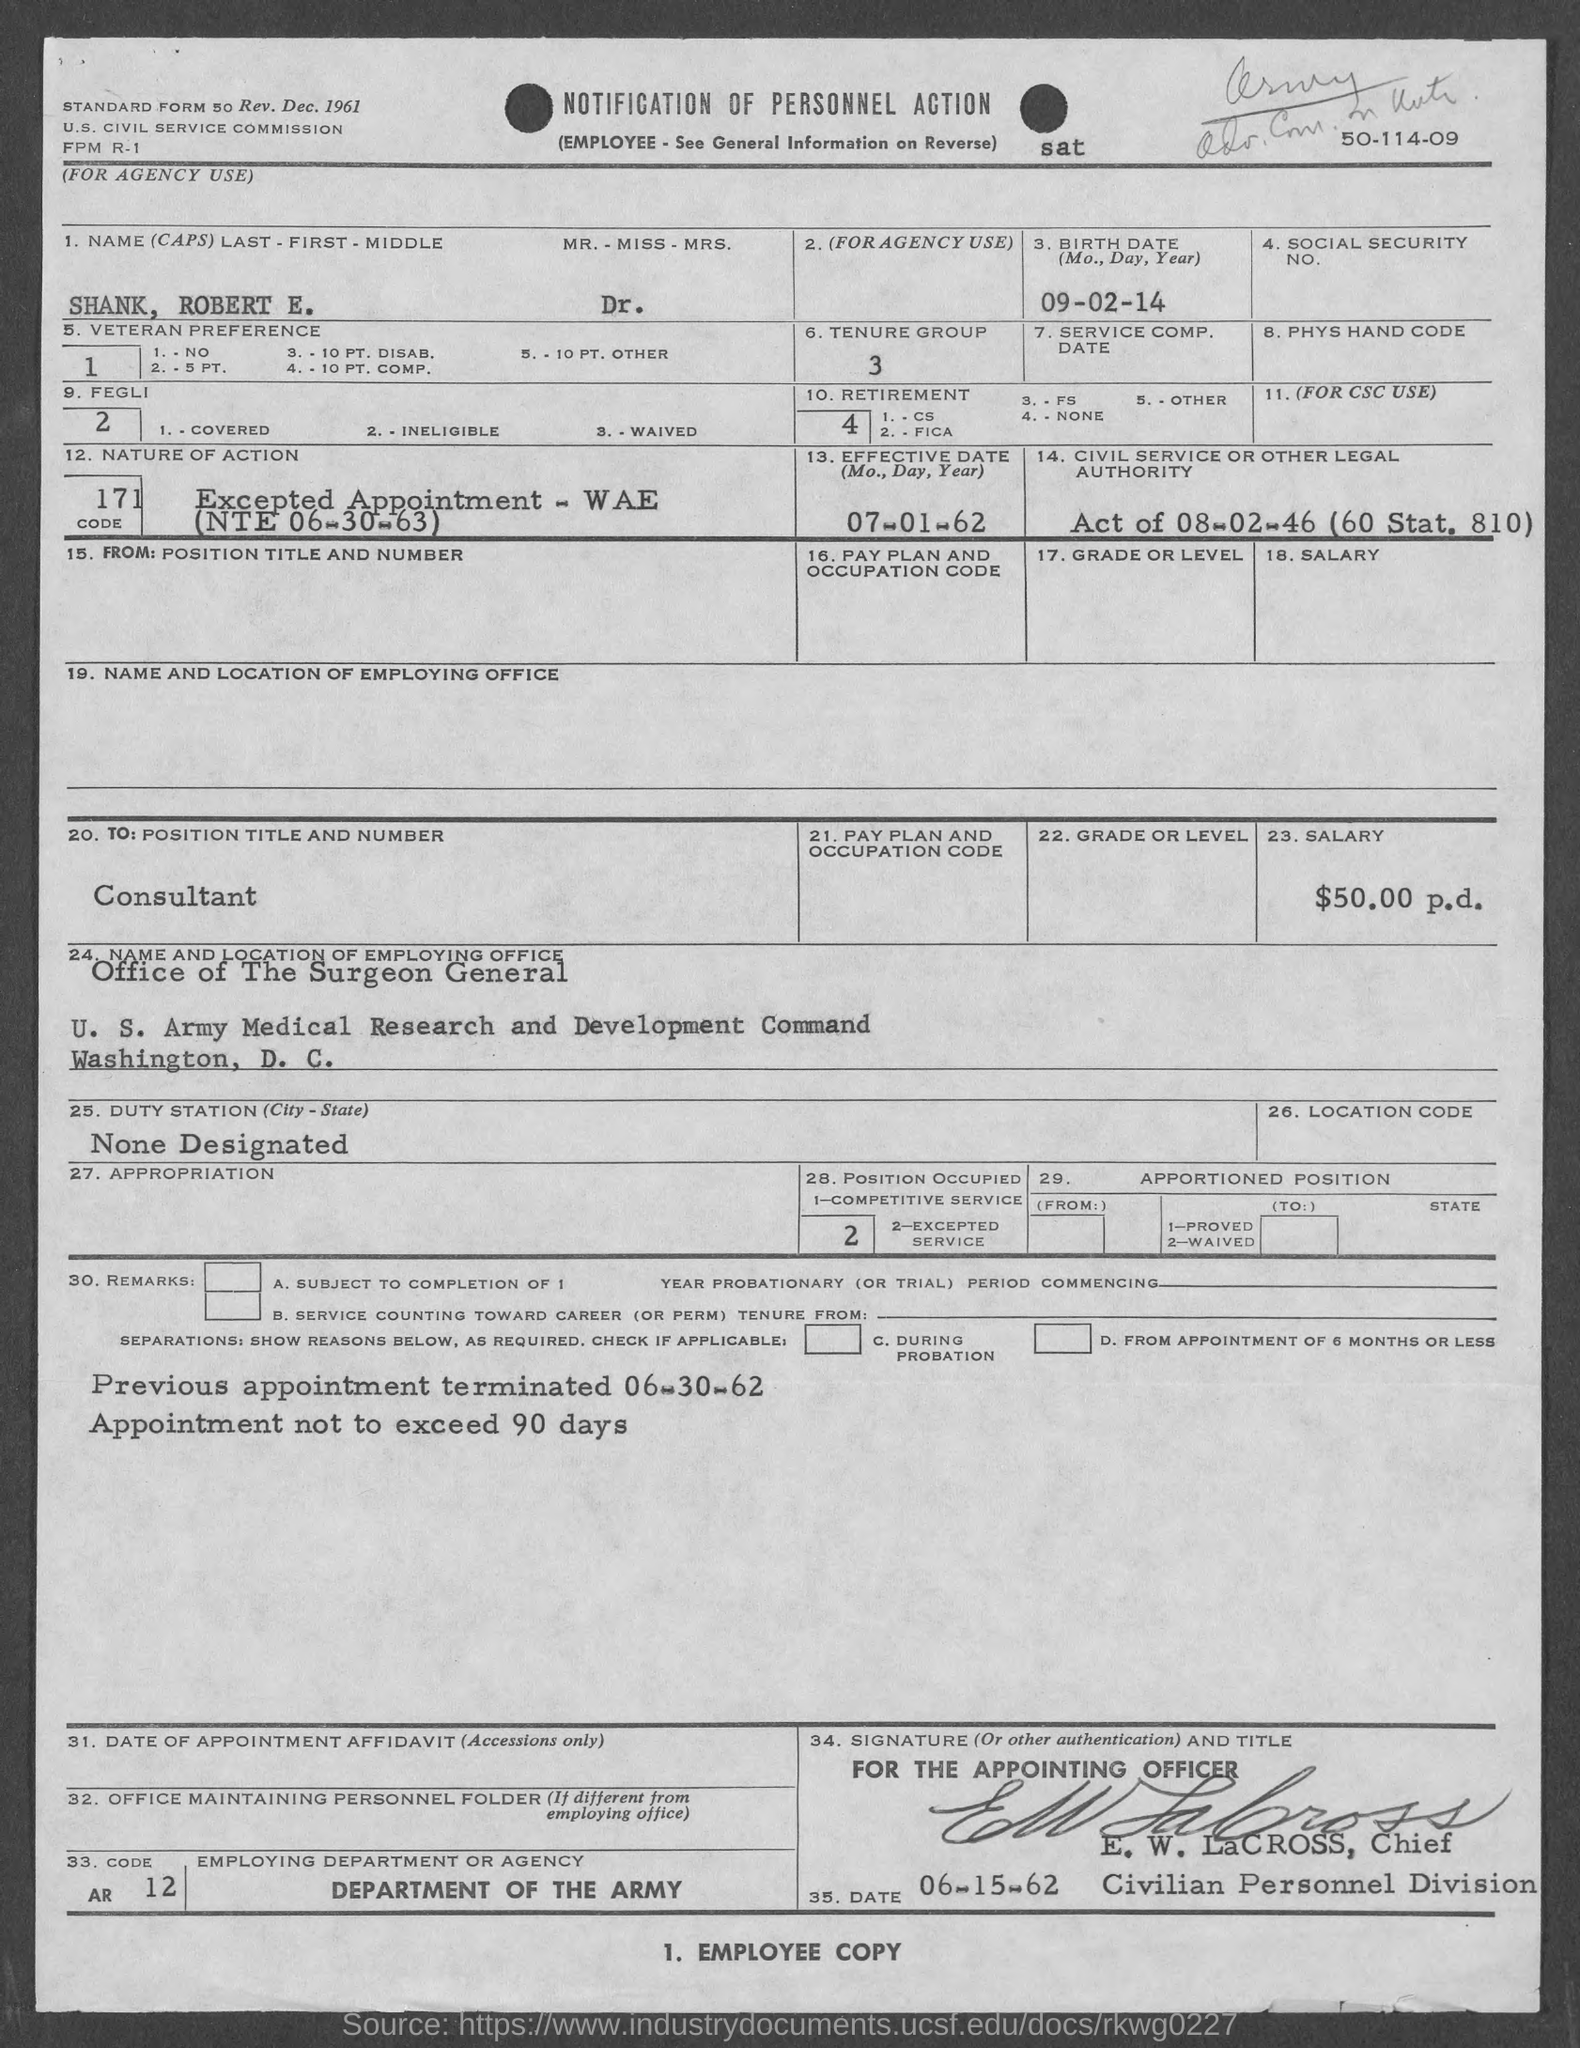Mention a couple of crucial points in this snapshot. The tenure group is comprised of individuals who are in the process of being granted tenure, with a minimum service requirement of three years. The Department of the Army is the employing department or agency. The name of the person in the form is Shank, Robert E. DR. The effective date of July 1, 1962, is the date upon which the stated or described event or situation takes place or becomes enforceable or active. The birth date of Shank, Robert E. is September 2, 2014. 